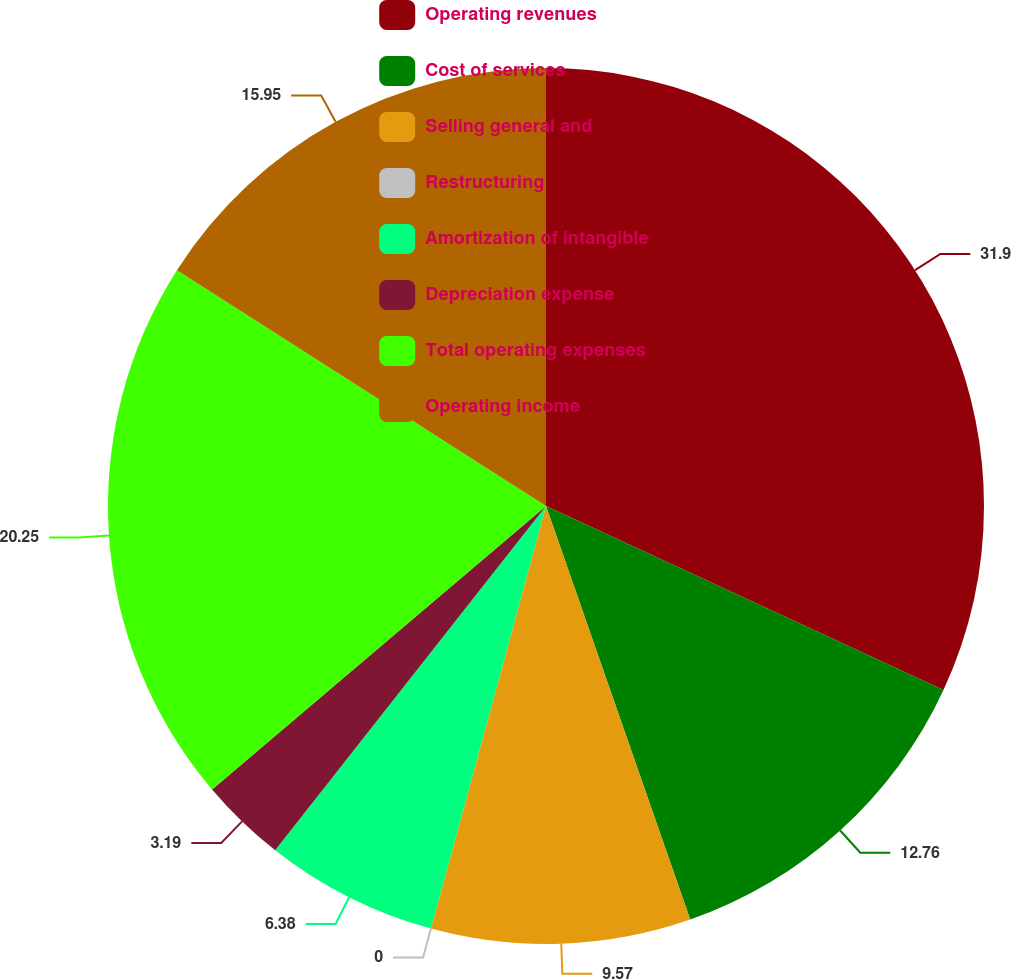Convert chart to OTSL. <chart><loc_0><loc_0><loc_500><loc_500><pie_chart><fcel>Operating revenues<fcel>Cost of services<fcel>Selling general and<fcel>Restructuring<fcel>Amortization of intangible<fcel>Depreciation expense<fcel>Total operating expenses<fcel>Operating income<nl><fcel>31.9%<fcel>12.76%<fcel>9.57%<fcel>0.0%<fcel>6.38%<fcel>3.19%<fcel>20.25%<fcel>15.95%<nl></chart> 